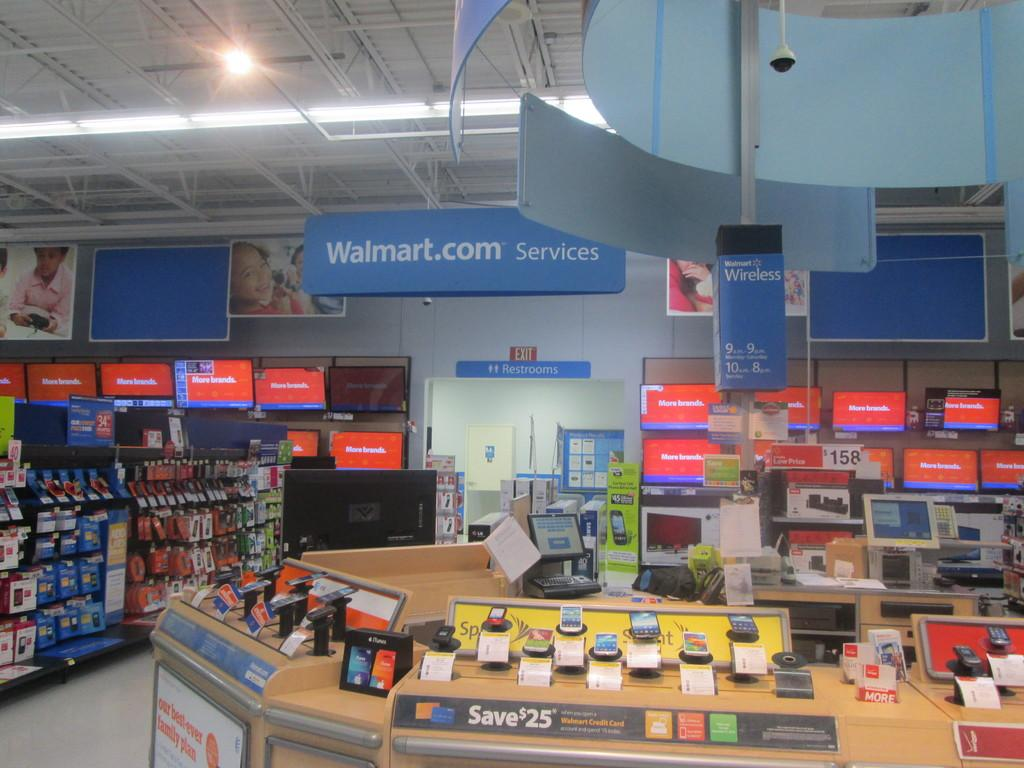<image>
Summarize the visual content of the image. A display in walmart with a sign advertising save 25 dollars. 